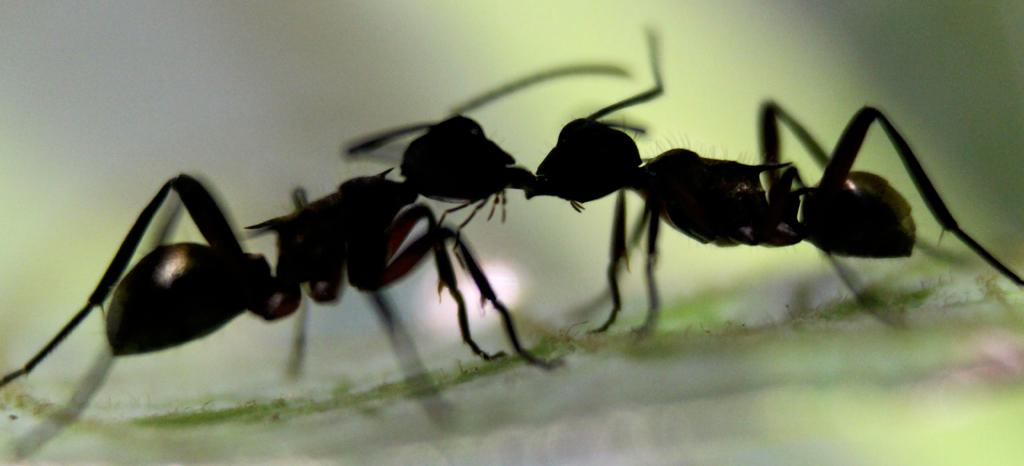What creatures can be seen in the image? There are two ants in the image. Where are the ants located? The ants are on a surface. Can you describe the background of the image? The background of the image is blurred. What type of zipper can be seen on the ants in the image? There are no zippers present on the ants in the image, as ants do not have zippers. 